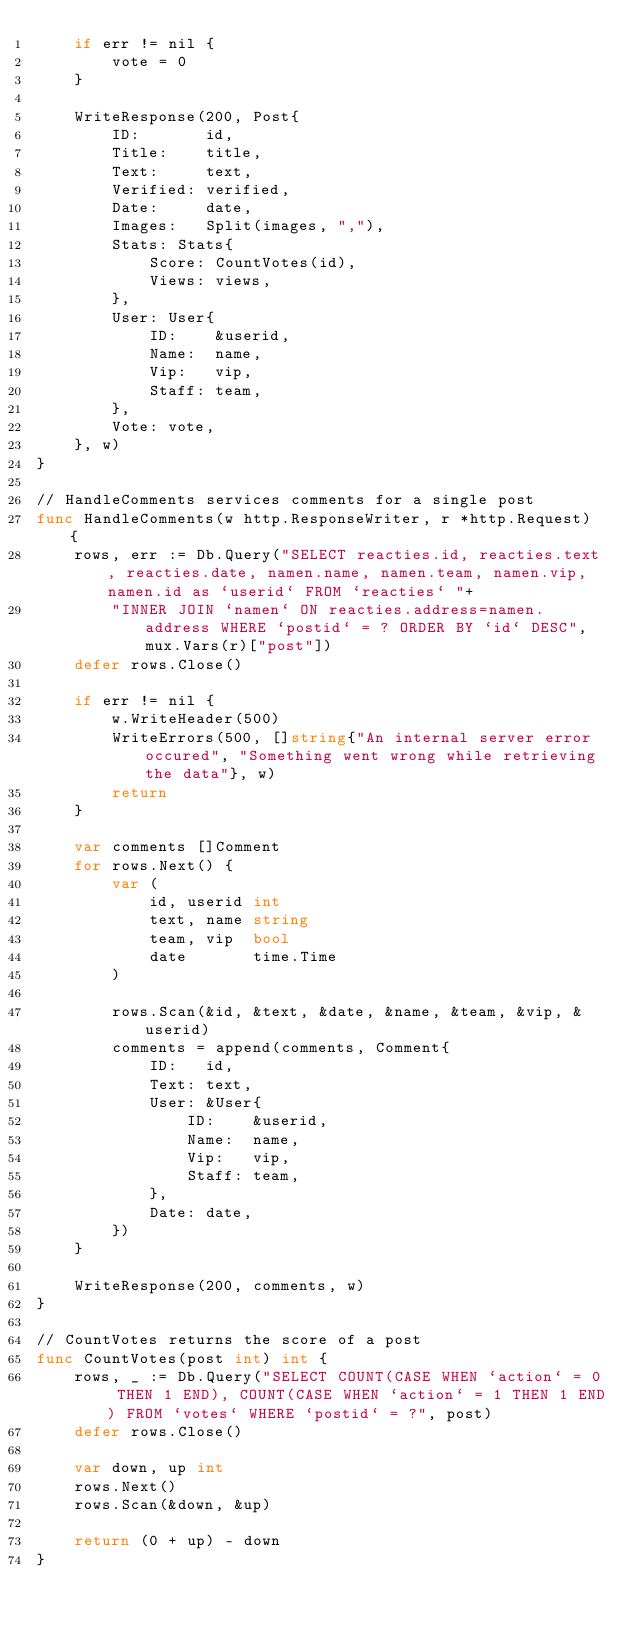<code> <loc_0><loc_0><loc_500><loc_500><_Go_>	if err != nil {
		vote = 0
	}

	WriteResponse(200, Post{
		ID:       id,
		Title:    title,
		Text:     text,
		Verified: verified,
		Date:     date,
		Images:   Split(images, ","),
		Stats: Stats{
			Score: CountVotes(id),
			Views: views,
		},
		User: User{
			ID:    &userid,
			Name:  name,
			Vip:   vip,
			Staff: team,
		},
		Vote: vote,
	}, w)
}

// HandleComments services comments for a single post
func HandleComments(w http.ResponseWriter, r *http.Request) {
	rows, err := Db.Query("SELECT reacties.id, reacties.text, reacties.date, namen.name, namen.team, namen.vip, namen.id as `userid` FROM `reacties` "+
		"INNER JOIN `namen` ON reacties.address=namen.address WHERE `postid` = ? ORDER BY `id` DESC", mux.Vars(r)["post"])
	defer rows.Close()

	if err != nil {
		w.WriteHeader(500)
		WriteErrors(500, []string{"An internal server error occured", "Something went wrong while retrieving the data"}, w)
		return
	}

	var comments []Comment
	for rows.Next() {
		var (
			id, userid int
			text, name string
			team, vip  bool
			date       time.Time
		)

		rows.Scan(&id, &text, &date, &name, &team, &vip, &userid)
		comments = append(comments, Comment{
			ID:   id,
			Text: text,
			User: &User{
				ID:    &userid,
				Name:  name,
				Vip:   vip,
				Staff: team,
			},
			Date: date,
		})
	}

	WriteResponse(200, comments, w)
}

// CountVotes returns the score of a post
func CountVotes(post int) int {
	rows, _ := Db.Query("SELECT COUNT(CASE WHEN `action` = 0 THEN 1 END), COUNT(CASE WHEN `action` = 1 THEN 1 END) FROM `votes` WHERE `postid` = ?", post)
	defer rows.Close()

	var down, up int
	rows.Next()
	rows.Scan(&down, &up)

	return (0 + up) - down
}
</code> 